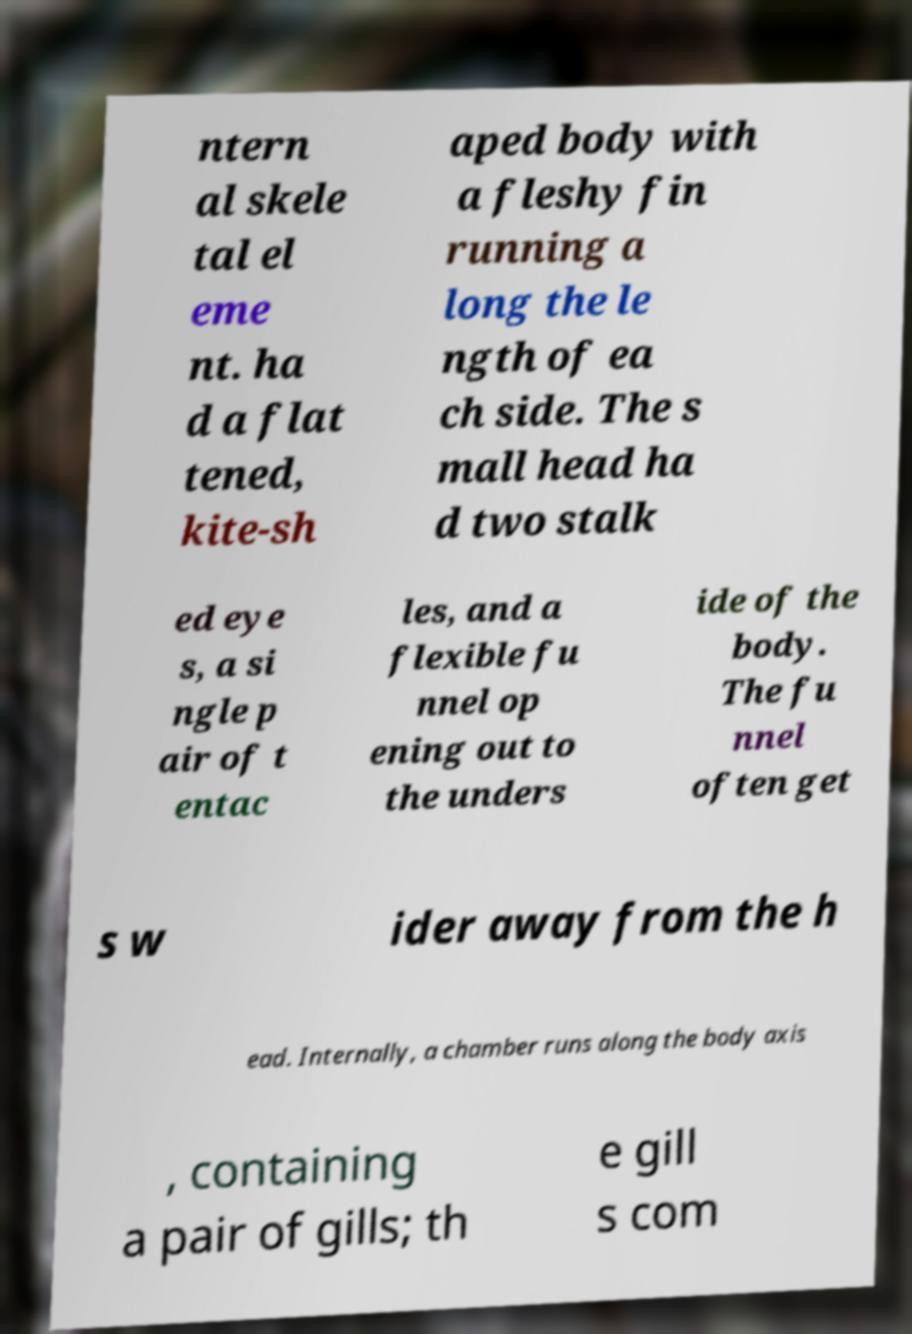Can you accurately transcribe the text from the provided image for me? ntern al skele tal el eme nt. ha d a flat tened, kite-sh aped body with a fleshy fin running a long the le ngth of ea ch side. The s mall head ha d two stalk ed eye s, a si ngle p air of t entac les, and a flexible fu nnel op ening out to the unders ide of the body. The fu nnel often get s w ider away from the h ead. Internally, a chamber runs along the body axis , containing a pair of gills; th e gill s com 